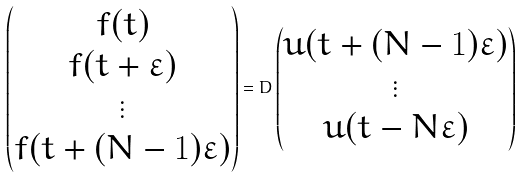Convert formula to latex. <formula><loc_0><loc_0><loc_500><loc_500>\begin{pmatrix} f ( t ) \\ f ( t + \varepsilon ) \\ \vdots \\ f ( t + ( N - 1 ) \varepsilon ) \end{pmatrix} = D \begin{pmatrix} u ( t + ( N - 1 ) \varepsilon ) \\ \vdots \\ u ( t - N \varepsilon ) \end{pmatrix}</formula> 